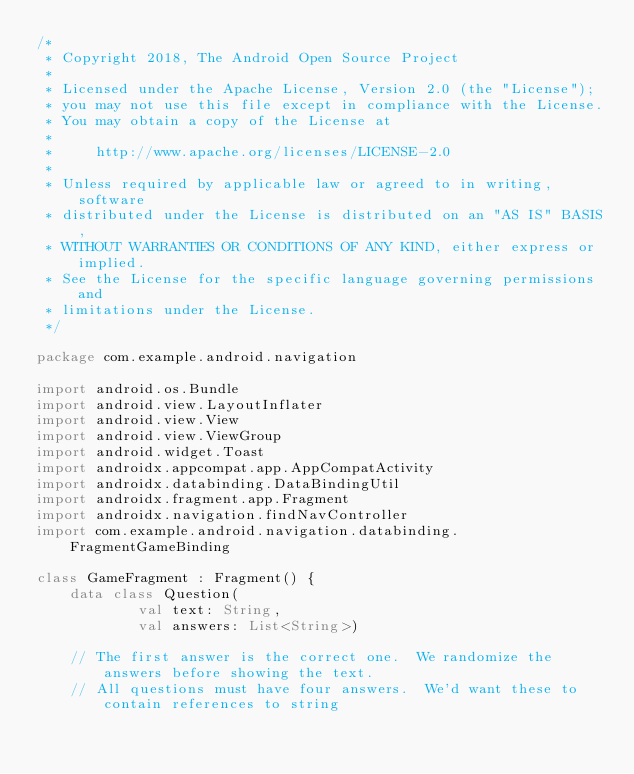<code> <loc_0><loc_0><loc_500><loc_500><_Kotlin_>/*
 * Copyright 2018, The Android Open Source Project
 *
 * Licensed under the Apache License, Version 2.0 (the "License");
 * you may not use this file except in compliance with the License.
 * You may obtain a copy of the License at
 *
 *     http://www.apache.org/licenses/LICENSE-2.0
 *
 * Unless required by applicable law or agreed to in writing, software
 * distributed under the License is distributed on an "AS IS" BASIS,
 * WITHOUT WARRANTIES OR CONDITIONS OF ANY KIND, either express or implied.
 * See the License for the specific language governing permissions and
 * limitations under the License.
 */

package com.example.android.navigation

import android.os.Bundle
import android.view.LayoutInflater
import android.view.View
import android.view.ViewGroup
import android.widget.Toast
import androidx.appcompat.app.AppCompatActivity
import androidx.databinding.DataBindingUtil
import androidx.fragment.app.Fragment
import androidx.navigation.findNavController
import com.example.android.navigation.databinding.FragmentGameBinding

class GameFragment : Fragment() {
    data class Question(
            val text: String,
            val answers: List<String>)

    // The first answer is the correct one.  We randomize the answers before showing the text.
    // All questions must have four answers.  We'd want these to contain references to string</code> 